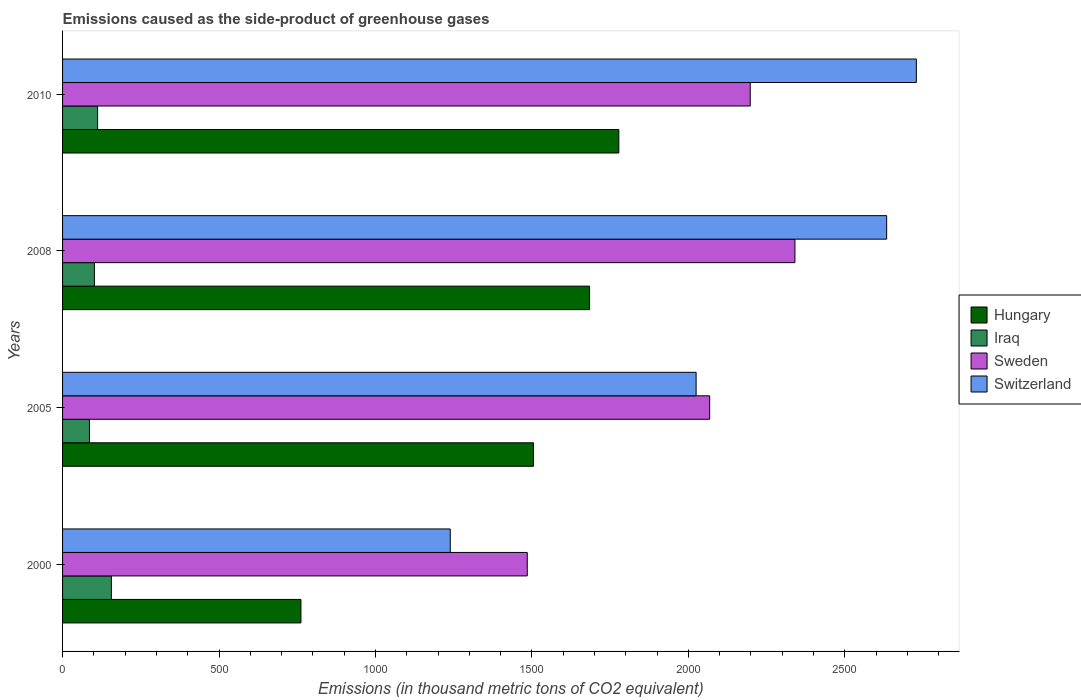How many groups of bars are there?
Your answer should be compact. 4. Are the number of bars per tick equal to the number of legend labels?
Your answer should be compact. Yes. How many bars are there on the 3rd tick from the top?
Offer a terse response. 4. How many bars are there on the 2nd tick from the bottom?
Your answer should be very brief. 4. In how many cases, is the number of bars for a given year not equal to the number of legend labels?
Provide a short and direct response. 0. What is the emissions caused as the side-product of greenhouse gases in Hungary in 2005?
Offer a terse response. 1505.1. Across all years, what is the maximum emissions caused as the side-product of greenhouse gases in Switzerland?
Give a very brief answer. 2729. Across all years, what is the minimum emissions caused as the side-product of greenhouse gases in Sweden?
Your answer should be very brief. 1485.3. In which year was the emissions caused as the side-product of greenhouse gases in Sweden maximum?
Make the answer very short. 2008. What is the total emissions caused as the side-product of greenhouse gases in Iraq in the graph?
Offer a very short reply. 455.8. What is the difference between the emissions caused as the side-product of greenhouse gases in Iraq in 2000 and that in 2005?
Provide a short and direct response. 70.1. What is the difference between the emissions caused as the side-product of greenhouse gases in Switzerland in 2010 and the emissions caused as the side-product of greenhouse gases in Hungary in 2005?
Ensure brevity in your answer.  1223.9. What is the average emissions caused as the side-product of greenhouse gases in Switzerland per year?
Make the answer very short. 2156.82. In the year 2010, what is the difference between the emissions caused as the side-product of greenhouse gases in Iraq and emissions caused as the side-product of greenhouse gases in Hungary?
Offer a very short reply. -1666. What is the ratio of the emissions caused as the side-product of greenhouse gases in Hungary in 2000 to that in 2010?
Ensure brevity in your answer.  0.43. Is the difference between the emissions caused as the side-product of greenhouse gases in Iraq in 2008 and 2010 greater than the difference between the emissions caused as the side-product of greenhouse gases in Hungary in 2008 and 2010?
Give a very brief answer. Yes. What is the difference between the highest and the second highest emissions caused as the side-product of greenhouse gases in Sweden?
Give a very brief answer. 142.9. What is the difference between the highest and the lowest emissions caused as the side-product of greenhouse gases in Switzerland?
Offer a terse response. 1489.8. Is it the case that in every year, the sum of the emissions caused as the side-product of greenhouse gases in Iraq and emissions caused as the side-product of greenhouse gases in Hungary is greater than the sum of emissions caused as the side-product of greenhouse gases in Switzerland and emissions caused as the side-product of greenhouse gases in Sweden?
Provide a short and direct response. No. What does the 4th bar from the top in 2010 represents?
Your response must be concise. Hungary. Are all the bars in the graph horizontal?
Give a very brief answer. Yes. How many years are there in the graph?
Make the answer very short. 4. Are the values on the major ticks of X-axis written in scientific E-notation?
Your answer should be compact. No. Does the graph contain any zero values?
Offer a very short reply. No. Where does the legend appear in the graph?
Provide a succinct answer. Center right. How are the legend labels stacked?
Provide a short and direct response. Vertical. What is the title of the graph?
Ensure brevity in your answer.  Emissions caused as the side-product of greenhouse gases. Does "Russian Federation" appear as one of the legend labels in the graph?
Ensure brevity in your answer.  No. What is the label or title of the X-axis?
Make the answer very short. Emissions (in thousand metric tons of CO2 equivalent). What is the Emissions (in thousand metric tons of CO2 equivalent) of Hungary in 2000?
Provide a short and direct response. 761.9. What is the Emissions (in thousand metric tons of CO2 equivalent) in Iraq in 2000?
Your answer should be very brief. 156.1. What is the Emissions (in thousand metric tons of CO2 equivalent) in Sweden in 2000?
Give a very brief answer. 1485.3. What is the Emissions (in thousand metric tons of CO2 equivalent) in Switzerland in 2000?
Ensure brevity in your answer.  1239.2. What is the Emissions (in thousand metric tons of CO2 equivalent) in Hungary in 2005?
Make the answer very short. 1505.1. What is the Emissions (in thousand metric tons of CO2 equivalent) of Iraq in 2005?
Keep it short and to the point. 86. What is the Emissions (in thousand metric tons of CO2 equivalent) of Sweden in 2005?
Ensure brevity in your answer.  2068.4. What is the Emissions (in thousand metric tons of CO2 equivalent) of Switzerland in 2005?
Offer a very short reply. 2025. What is the Emissions (in thousand metric tons of CO2 equivalent) of Hungary in 2008?
Your answer should be compact. 1684.5. What is the Emissions (in thousand metric tons of CO2 equivalent) in Iraq in 2008?
Keep it short and to the point. 101.7. What is the Emissions (in thousand metric tons of CO2 equivalent) in Sweden in 2008?
Provide a succinct answer. 2340.9. What is the Emissions (in thousand metric tons of CO2 equivalent) of Switzerland in 2008?
Your answer should be very brief. 2634.1. What is the Emissions (in thousand metric tons of CO2 equivalent) of Hungary in 2010?
Offer a very short reply. 1778. What is the Emissions (in thousand metric tons of CO2 equivalent) in Iraq in 2010?
Offer a very short reply. 112. What is the Emissions (in thousand metric tons of CO2 equivalent) of Sweden in 2010?
Provide a succinct answer. 2198. What is the Emissions (in thousand metric tons of CO2 equivalent) in Switzerland in 2010?
Ensure brevity in your answer.  2729. Across all years, what is the maximum Emissions (in thousand metric tons of CO2 equivalent) of Hungary?
Offer a very short reply. 1778. Across all years, what is the maximum Emissions (in thousand metric tons of CO2 equivalent) in Iraq?
Your answer should be very brief. 156.1. Across all years, what is the maximum Emissions (in thousand metric tons of CO2 equivalent) in Sweden?
Ensure brevity in your answer.  2340.9. Across all years, what is the maximum Emissions (in thousand metric tons of CO2 equivalent) of Switzerland?
Your response must be concise. 2729. Across all years, what is the minimum Emissions (in thousand metric tons of CO2 equivalent) of Hungary?
Give a very brief answer. 761.9. Across all years, what is the minimum Emissions (in thousand metric tons of CO2 equivalent) of Iraq?
Your answer should be compact. 86. Across all years, what is the minimum Emissions (in thousand metric tons of CO2 equivalent) in Sweden?
Provide a succinct answer. 1485.3. Across all years, what is the minimum Emissions (in thousand metric tons of CO2 equivalent) in Switzerland?
Make the answer very short. 1239.2. What is the total Emissions (in thousand metric tons of CO2 equivalent) of Hungary in the graph?
Offer a very short reply. 5729.5. What is the total Emissions (in thousand metric tons of CO2 equivalent) in Iraq in the graph?
Keep it short and to the point. 455.8. What is the total Emissions (in thousand metric tons of CO2 equivalent) of Sweden in the graph?
Make the answer very short. 8092.6. What is the total Emissions (in thousand metric tons of CO2 equivalent) of Switzerland in the graph?
Make the answer very short. 8627.3. What is the difference between the Emissions (in thousand metric tons of CO2 equivalent) in Hungary in 2000 and that in 2005?
Keep it short and to the point. -743.2. What is the difference between the Emissions (in thousand metric tons of CO2 equivalent) of Iraq in 2000 and that in 2005?
Your response must be concise. 70.1. What is the difference between the Emissions (in thousand metric tons of CO2 equivalent) of Sweden in 2000 and that in 2005?
Your response must be concise. -583.1. What is the difference between the Emissions (in thousand metric tons of CO2 equivalent) of Switzerland in 2000 and that in 2005?
Provide a short and direct response. -785.8. What is the difference between the Emissions (in thousand metric tons of CO2 equivalent) in Hungary in 2000 and that in 2008?
Provide a short and direct response. -922.6. What is the difference between the Emissions (in thousand metric tons of CO2 equivalent) of Iraq in 2000 and that in 2008?
Give a very brief answer. 54.4. What is the difference between the Emissions (in thousand metric tons of CO2 equivalent) in Sweden in 2000 and that in 2008?
Provide a short and direct response. -855.6. What is the difference between the Emissions (in thousand metric tons of CO2 equivalent) of Switzerland in 2000 and that in 2008?
Provide a short and direct response. -1394.9. What is the difference between the Emissions (in thousand metric tons of CO2 equivalent) of Hungary in 2000 and that in 2010?
Offer a terse response. -1016.1. What is the difference between the Emissions (in thousand metric tons of CO2 equivalent) in Iraq in 2000 and that in 2010?
Make the answer very short. 44.1. What is the difference between the Emissions (in thousand metric tons of CO2 equivalent) in Sweden in 2000 and that in 2010?
Your answer should be compact. -712.7. What is the difference between the Emissions (in thousand metric tons of CO2 equivalent) in Switzerland in 2000 and that in 2010?
Provide a succinct answer. -1489.8. What is the difference between the Emissions (in thousand metric tons of CO2 equivalent) of Hungary in 2005 and that in 2008?
Offer a very short reply. -179.4. What is the difference between the Emissions (in thousand metric tons of CO2 equivalent) of Iraq in 2005 and that in 2008?
Your answer should be compact. -15.7. What is the difference between the Emissions (in thousand metric tons of CO2 equivalent) of Sweden in 2005 and that in 2008?
Provide a succinct answer. -272.5. What is the difference between the Emissions (in thousand metric tons of CO2 equivalent) of Switzerland in 2005 and that in 2008?
Offer a terse response. -609.1. What is the difference between the Emissions (in thousand metric tons of CO2 equivalent) of Hungary in 2005 and that in 2010?
Your answer should be very brief. -272.9. What is the difference between the Emissions (in thousand metric tons of CO2 equivalent) of Sweden in 2005 and that in 2010?
Your answer should be compact. -129.6. What is the difference between the Emissions (in thousand metric tons of CO2 equivalent) of Switzerland in 2005 and that in 2010?
Your answer should be compact. -704. What is the difference between the Emissions (in thousand metric tons of CO2 equivalent) of Hungary in 2008 and that in 2010?
Your answer should be very brief. -93.5. What is the difference between the Emissions (in thousand metric tons of CO2 equivalent) of Sweden in 2008 and that in 2010?
Give a very brief answer. 142.9. What is the difference between the Emissions (in thousand metric tons of CO2 equivalent) in Switzerland in 2008 and that in 2010?
Provide a succinct answer. -94.9. What is the difference between the Emissions (in thousand metric tons of CO2 equivalent) in Hungary in 2000 and the Emissions (in thousand metric tons of CO2 equivalent) in Iraq in 2005?
Make the answer very short. 675.9. What is the difference between the Emissions (in thousand metric tons of CO2 equivalent) of Hungary in 2000 and the Emissions (in thousand metric tons of CO2 equivalent) of Sweden in 2005?
Offer a very short reply. -1306.5. What is the difference between the Emissions (in thousand metric tons of CO2 equivalent) of Hungary in 2000 and the Emissions (in thousand metric tons of CO2 equivalent) of Switzerland in 2005?
Your response must be concise. -1263.1. What is the difference between the Emissions (in thousand metric tons of CO2 equivalent) of Iraq in 2000 and the Emissions (in thousand metric tons of CO2 equivalent) of Sweden in 2005?
Offer a very short reply. -1912.3. What is the difference between the Emissions (in thousand metric tons of CO2 equivalent) in Iraq in 2000 and the Emissions (in thousand metric tons of CO2 equivalent) in Switzerland in 2005?
Your response must be concise. -1868.9. What is the difference between the Emissions (in thousand metric tons of CO2 equivalent) in Sweden in 2000 and the Emissions (in thousand metric tons of CO2 equivalent) in Switzerland in 2005?
Your answer should be very brief. -539.7. What is the difference between the Emissions (in thousand metric tons of CO2 equivalent) in Hungary in 2000 and the Emissions (in thousand metric tons of CO2 equivalent) in Iraq in 2008?
Your response must be concise. 660.2. What is the difference between the Emissions (in thousand metric tons of CO2 equivalent) of Hungary in 2000 and the Emissions (in thousand metric tons of CO2 equivalent) of Sweden in 2008?
Keep it short and to the point. -1579. What is the difference between the Emissions (in thousand metric tons of CO2 equivalent) in Hungary in 2000 and the Emissions (in thousand metric tons of CO2 equivalent) in Switzerland in 2008?
Your response must be concise. -1872.2. What is the difference between the Emissions (in thousand metric tons of CO2 equivalent) in Iraq in 2000 and the Emissions (in thousand metric tons of CO2 equivalent) in Sweden in 2008?
Provide a short and direct response. -2184.8. What is the difference between the Emissions (in thousand metric tons of CO2 equivalent) of Iraq in 2000 and the Emissions (in thousand metric tons of CO2 equivalent) of Switzerland in 2008?
Your response must be concise. -2478. What is the difference between the Emissions (in thousand metric tons of CO2 equivalent) in Sweden in 2000 and the Emissions (in thousand metric tons of CO2 equivalent) in Switzerland in 2008?
Your answer should be compact. -1148.8. What is the difference between the Emissions (in thousand metric tons of CO2 equivalent) of Hungary in 2000 and the Emissions (in thousand metric tons of CO2 equivalent) of Iraq in 2010?
Provide a short and direct response. 649.9. What is the difference between the Emissions (in thousand metric tons of CO2 equivalent) of Hungary in 2000 and the Emissions (in thousand metric tons of CO2 equivalent) of Sweden in 2010?
Your response must be concise. -1436.1. What is the difference between the Emissions (in thousand metric tons of CO2 equivalent) of Hungary in 2000 and the Emissions (in thousand metric tons of CO2 equivalent) of Switzerland in 2010?
Provide a succinct answer. -1967.1. What is the difference between the Emissions (in thousand metric tons of CO2 equivalent) of Iraq in 2000 and the Emissions (in thousand metric tons of CO2 equivalent) of Sweden in 2010?
Keep it short and to the point. -2041.9. What is the difference between the Emissions (in thousand metric tons of CO2 equivalent) in Iraq in 2000 and the Emissions (in thousand metric tons of CO2 equivalent) in Switzerland in 2010?
Make the answer very short. -2572.9. What is the difference between the Emissions (in thousand metric tons of CO2 equivalent) of Sweden in 2000 and the Emissions (in thousand metric tons of CO2 equivalent) of Switzerland in 2010?
Offer a terse response. -1243.7. What is the difference between the Emissions (in thousand metric tons of CO2 equivalent) of Hungary in 2005 and the Emissions (in thousand metric tons of CO2 equivalent) of Iraq in 2008?
Provide a short and direct response. 1403.4. What is the difference between the Emissions (in thousand metric tons of CO2 equivalent) of Hungary in 2005 and the Emissions (in thousand metric tons of CO2 equivalent) of Sweden in 2008?
Make the answer very short. -835.8. What is the difference between the Emissions (in thousand metric tons of CO2 equivalent) in Hungary in 2005 and the Emissions (in thousand metric tons of CO2 equivalent) in Switzerland in 2008?
Give a very brief answer. -1129. What is the difference between the Emissions (in thousand metric tons of CO2 equivalent) of Iraq in 2005 and the Emissions (in thousand metric tons of CO2 equivalent) of Sweden in 2008?
Make the answer very short. -2254.9. What is the difference between the Emissions (in thousand metric tons of CO2 equivalent) in Iraq in 2005 and the Emissions (in thousand metric tons of CO2 equivalent) in Switzerland in 2008?
Your answer should be very brief. -2548.1. What is the difference between the Emissions (in thousand metric tons of CO2 equivalent) in Sweden in 2005 and the Emissions (in thousand metric tons of CO2 equivalent) in Switzerland in 2008?
Keep it short and to the point. -565.7. What is the difference between the Emissions (in thousand metric tons of CO2 equivalent) of Hungary in 2005 and the Emissions (in thousand metric tons of CO2 equivalent) of Iraq in 2010?
Offer a terse response. 1393.1. What is the difference between the Emissions (in thousand metric tons of CO2 equivalent) of Hungary in 2005 and the Emissions (in thousand metric tons of CO2 equivalent) of Sweden in 2010?
Provide a succinct answer. -692.9. What is the difference between the Emissions (in thousand metric tons of CO2 equivalent) of Hungary in 2005 and the Emissions (in thousand metric tons of CO2 equivalent) of Switzerland in 2010?
Give a very brief answer. -1223.9. What is the difference between the Emissions (in thousand metric tons of CO2 equivalent) in Iraq in 2005 and the Emissions (in thousand metric tons of CO2 equivalent) in Sweden in 2010?
Provide a succinct answer. -2112. What is the difference between the Emissions (in thousand metric tons of CO2 equivalent) of Iraq in 2005 and the Emissions (in thousand metric tons of CO2 equivalent) of Switzerland in 2010?
Your response must be concise. -2643. What is the difference between the Emissions (in thousand metric tons of CO2 equivalent) in Sweden in 2005 and the Emissions (in thousand metric tons of CO2 equivalent) in Switzerland in 2010?
Make the answer very short. -660.6. What is the difference between the Emissions (in thousand metric tons of CO2 equivalent) of Hungary in 2008 and the Emissions (in thousand metric tons of CO2 equivalent) of Iraq in 2010?
Ensure brevity in your answer.  1572.5. What is the difference between the Emissions (in thousand metric tons of CO2 equivalent) of Hungary in 2008 and the Emissions (in thousand metric tons of CO2 equivalent) of Sweden in 2010?
Your answer should be compact. -513.5. What is the difference between the Emissions (in thousand metric tons of CO2 equivalent) of Hungary in 2008 and the Emissions (in thousand metric tons of CO2 equivalent) of Switzerland in 2010?
Give a very brief answer. -1044.5. What is the difference between the Emissions (in thousand metric tons of CO2 equivalent) in Iraq in 2008 and the Emissions (in thousand metric tons of CO2 equivalent) in Sweden in 2010?
Provide a short and direct response. -2096.3. What is the difference between the Emissions (in thousand metric tons of CO2 equivalent) in Iraq in 2008 and the Emissions (in thousand metric tons of CO2 equivalent) in Switzerland in 2010?
Your answer should be compact. -2627.3. What is the difference between the Emissions (in thousand metric tons of CO2 equivalent) in Sweden in 2008 and the Emissions (in thousand metric tons of CO2 equivalent) in Switzerland in 2010?
Make the answer very short. -388.1. What is the average Emissions (in thousand metric tons of CO2 equivalent) in Hungary per year?
Offer a terse response. 1432.38. What is the average Emissions (in thousand metric tons of CO2 equivalent) of Iraq per year?
Ensure brevity in your answer.  113.95. What is the average Emissions (in thousand metric tons of CO2 equivalent) in Sweden per year?
Ensure brevity in your answer.  2023.15. What is the average Emissions (in thousand metric tons of CO2 equivalent) in Switzerland per year?
Keep it short and to the point. 2156.82. In the year 2000, what is the difference between the Emissions (in thousand metric tons of CO2 equivalent) in Hungary and Emissions (in thousand metric tons of CO2 equivalent) in Iraq?
Your answer should be very brief. 605.8. In the year 2000, what is the difference between the Emissions (in thousand metric tons of CO2 equivalent) in Hungary and Emissions (in thousand metric tons of CO2 equivalent) in Sweden?
Make the answer very short. -723.4. In the year 2000, what is the difference between the Emissions (in thousand metric tons of CO2 equivalent) in Hungary and Emissions (in thousand metric tons of CO2 equivalent) in Switzerland?
Offer a very short reply. -477.3. In the year 2000, what is the difference between the Emissions (in thousand metric tons of CO2 equivalent) of Iraq and Emissions (in thousand metric tons of CO2 equivalent) of Sweden?
Provide a succinct answer. -1329.2. In the year 2000, what is the difference between the Emissions (in thousand metric tons of CO2 equivalent) of Iraq and Emissions (in thousand metric tons of CO2 equivalent) of Switzerland?
Give a very brief answer. -1083.1. In the year 2000, what is the difference between the Emissions (in thousand metric tons of CO2 equivalent) in Sweden and Emissions (in thousand metric tons of CO2 equivalent) in Switzerland?
Your answer should be compact. 246.1. In the year 2005, what is the difference between the Emissions (in thousand metric tons of CO2 equivalent) in Hungary and Emissions (in thousand metric tons of CO2 equivalent) in Iraq?
Give a very brief answer. 1419.1. In the year 2005, what is the difference between the Emissions (in thousand metric tons of CO2 equivalent) of Hungary and Emissions (in thousand metric tons of CO2 equivalent) of Sweden?
Provide a succinct answer. -563.3. In the year 2005, what is the difference between the Emissions (in thousand metric tons of CO2 equivalent) of Hungary and Emissions (in thousand metric tons of CO2 equivalent) of Switzerland?
Your answer should be very brief. -519.9. In the year 2005, what is the difference between the Emissions (in thousand metric tons of CO2 equivalent) in Iraq and Emissions (in thousand metric tons of CO2 equivalent) in Sweden?
Make the answer very short. -1982.4. In the year 2005, what is the difference between the Emissions (in thousand metric tons of CO2 equivalent) in Iraq and Emissions (in thousand metric tons of CO2 equivalent) in Switzerland?
Offer a terse response. -1939. In the year 2005, what is the difference between the Emissions (in thousand metric tons of CO2 equivalent) of Sweden and Emissions (in thousand metric tons of CO2 equivalent) of Switzerland?
Give a very brief answer. 43.4. In the year 2008, what is the difference between the Emissions (in thousand metric tons of CO2 equivalent) in Hungary and Emissions (in thousand metric tons of CO2 equivalent) in Iraq?
Provide a succinct answer. 1582.8. In the year 2008, what is the difference between the Emissions (in thousand metric tons of CO2 equivalent) in Hungary and Emissions (in thousand metric tons of CO2 equivalent) in Sweden?
Keep it short and to the point. -656.4. In the year 2008, what is the difference between the Emissions (in thousand metric tons of CO2 equivalent) in Hungary and Emissions (in thousand metric tons of CO2 equivalent) in Switzerland?
Provide a short and direct response. -949.6. In the year 2008, what is the difference between the Emissions (in thousand metric tons of CO2 equivalent) of Iraq and Emissions (in thousand metric tons of CO2 equivalent) of Sweden?
Your response must be concise. -2239.2. In the year 2008, what is the difference between the Emissions (in thousand metric tons of CO2 equivalent) of Iraq and Emissions (in thousand metric tons of CO2 equivalent) of Switzerland?
Provide a short and direct response. -2532.4. In the year 2008, what is the difference between the Emissions (in thousand metric tons of CO2 equivalent) of Sweden and Emissions (in thousand metric tons of CO2 equivalent) of Switzerland?
Make the answer very short. -293.2. In the year 2010, what is the difference between the Emissions (in thousand metric tons of CO2 equivalent) of Hungary and Emissions (in thousand metric tons of CO2 equivalent) of Iraq?
Offer a very short reply. 1666. In the year 2010, what is the difference between the Emissions (in thousand metric tons of CO2 equivalent) of Hungary and Emissions (in thousand metric tons of CO2 equivalent) of Sweden?
Offer a very short reply. -420. In the year 2010, what is the difference between the Emissions (in thousand metric tons of CO2 equivalent) of Hungary and Emissions (in thousand metric tons of CO2 equivalent) of Switzerland?
Offer a terse response. -951. In the year 2010, what is the difference between the Emissions (in thousand metric tons of CO2 equivalent) in Iraq and Emissions (in thousand metric tons of CO2 equivalent) in Sweden?
Offer a very short reply. -2086. In the year 2010, what is the difference between the Emissions (in thousand metric tons of CO2 equivalent) of Iraq and Emissions (in thousand metric tons of CO2 equivalent) of Switzerland?
Give a very brief answer. -2617. In the year 2010, what is the difference between the Emissions (in thousand metric tons of CO2 equivalent) of Sweden and Emissions (in thousand metric tons of CO2 equivalent) of Switzerland?
Offer a very short reply. -531. What is the ratio of the Emissions (in thousand metric tons of CO2 equivalent) in Hungary in 2000 to that in 2005?
Offer a very short reply. 0.51. What is the ratio of the Emissions (in thousand metric tons of CO2 equivalent) of Iraq in 2000 to that in 2005?
Offer a terse response. 1.82. What is the ratio of the Emissions (in thousand metric tons of CO2 equivalent) in Sweden in 2000 to that in 2005?
Your response must be concise. 0.72. What is the ratio of the Emissions (in thousand metric tons of CO2 equivalent) of Switzerland in 2000 to that in 2005?
Your response must be concise. 0.61. What is the ratio of the Emissions (in thousand metric tons of CO2 equivalent) of Hungary in 2000 to that in 2008?
Offer a very short reply. 0.45. What is the ratio of the Emissions (in thousand metric tons of CO2 equivalent) in Iraq in 2000 to that in 2008?
Give a very brief answer. 1.53. What is the ratio of the Emissions (in thousand metric tons of CO2 equivalent) in Sweden in 2000 to that in 2008?
Provide a succinct answer. 0.63. What is the ratio of the Emissions (in thousand metric tons of CO2 equivalent) in Switzerland in 2000 to that in 2008?
Your answer should be compact. 0.47. What is the ratio of the Emissions (in thousand metric tons of CO2 equivalent) in Hungary in 2000 to that in 2010?
Provide a short and direct response. 0.43. What is the ratio of the Emissions (in thousand metric tons of CO2 equivalent) of Iraq in 2000 to that in 2010?
Your answer should be very brief. 1.39. What is the ratio of the Emissions (in thousand metric tons of CO2 equivalent) of Sweden in 2000 to that in 2010?
Your answer should be very brief. 0.68. What is the ratio of the Emissions (in thousand metric tons of CO2 equivalent) in Switzerland in 2000 to that in 2010?
Keep it short and to the point. 0.45. What is the ratio of the Emissions (in thousand metric tons of CO2 equivalent) in Hungary in 2005 to that in 2008?
Your answer should be very brief. 0.89. What is the ratio of the Emissions (in thousand metric tons of CO2 equivalent) of Iraq in 2005 to that in 2008?
Offer a very short reply. 0.85. What is the ratio of the Emissions (in thousand metric tons of CO2 equivalent) of Sweden in 2005 to that in 2008?
Your answer should be compact. 0.88. What is the ratio of the Emissions (in thousand metric tons of CO2 equivalent) of Switzerland in 2005 to that in 2008?
Ensure brevity in your answer.  0.77. What is the ratio of the Emissions (in thousand metric tons of CO2 equivalent) in Hungary in 2005 to that in 2010?
Offer a terse response. 0.85. What is the ratio of the Emissions (in thousand metric tons of CO2 equivalent) in Iraq in 2005 to that in 2010?
Offer a very short reply. 0.77. What is the ratio of the Emissions (in thousand metric tons of CO2 equivalent) in Sweden in 2005 to that in 2010?
Ensure brevity in your answer.  0.94. What is the ratio of the Emissions (in thousand metric tons of CO2 equivalent) of Switzerland in 2005 to that in 2010?
Offer a very short reply. 0.74. What is the ratio of the Emissions (in thousand metric tons of CO2 equivalent) in Iraq in 2008 to that in 2010?
Your response must be concise. 0.91. What is the ratio of the Emissions (in thousand metric tons of CO2 equivalent) of Sweden in 2008 to that in 2010?
Ensure brevity in your answer.  1.06. What is the ratio of the Emissions (in thousand metric tons of CO2 equivalent) of Switzerland in 2008 to that in 2010?
Offer a very short reply. 0.97. What is the difference between the highest and the second highest Emissions (in thousand metric tons of CO2 equivalent) of Hungary?
Offer a very short reply. 93.5. What is the difference between the highest and the second highest Emissions (in thousand metric tons of CO2 equivalent) of Iraq?
Offer a very short reply. 44.1. What is the difference between the highest and the second highest Emissions (in thousand metric tons of CO2 equivalent) of Sweden?
Your answer should be compact. 142.9. What is the difference between the highest and the second highest Emissions (in thousand metric tons of CO2 equivalent) in Switzerland?
Keep it short and to the point. 94.9. What is the difference between the highest and the lowest Emissions (in thousand metric tons of CO2 equivalent) of Hungary?
Your answer should be very brief. 1016.1. What is the difference between the highest and the lowest Emissions (in thousand metric tons of CO2 equivalent) of Iraq?
Your response must be concise. 70.1. What is the difference between the highest and the lowest Emissions (in thousand metric tons of CO2 equivalent) in Sweden?
Your answer should be compact. 855.6. What is the difference between the highest and the lowest Emissions (in thousand metric tons of CO2 equivalent) of Switzerland?
Your response must be concise. 1489.8. 